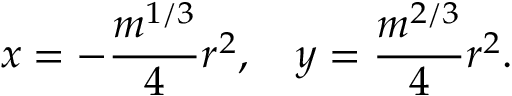Convert formula to latex. <formula><loc_0><loc_0><loc_500><loc_500>x = - { \frac { m ^ { 1 / 3 } } { 4 } } r ^ { 2 } , \quad y = { \frac { m ^ { 2 / 3 } } { 4 } } r ^ { 2 } .</formula> 